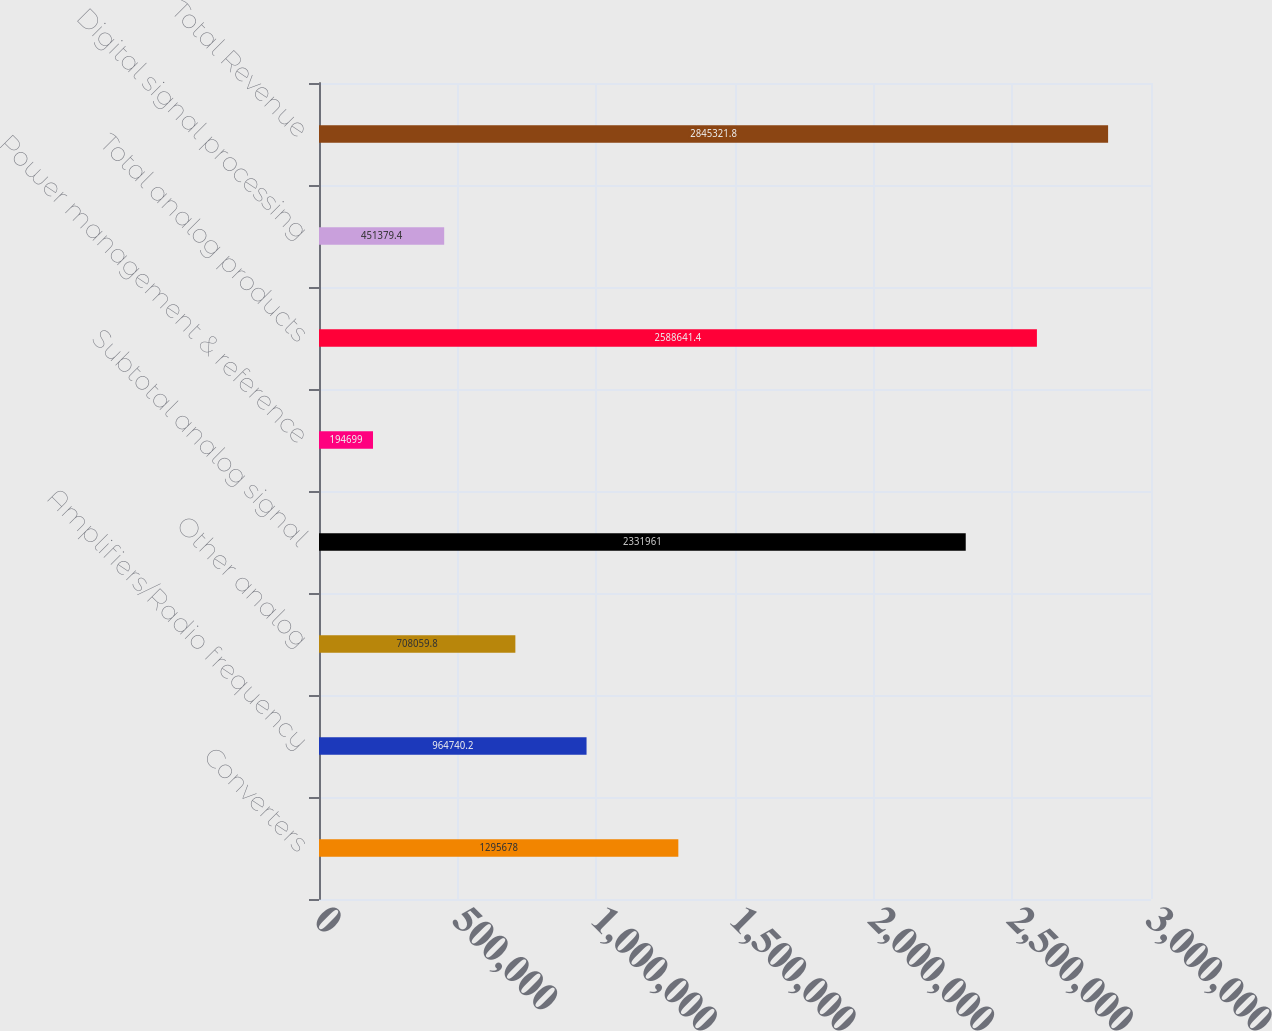Convert chart. <chart><loc_0><loc_0><loc_500><loc_500><bar_chart><fcel>Converters<fcel>Amplifiers/Radio frequency<fcel>Other analog<fcel>Subtotal analog signal<fcel>Power management & reference<fcel>Total analog products<fcel>Digital signal processing<fcel>Total Revenue<nl><fcel>1.29568e+06<fcel>964740<fcel>708060<fcel>2.33196e+06<fcel>194699<fcel>2.58864e+06<fcel>451379<fcel>2.84532e+06<nl></chart> 